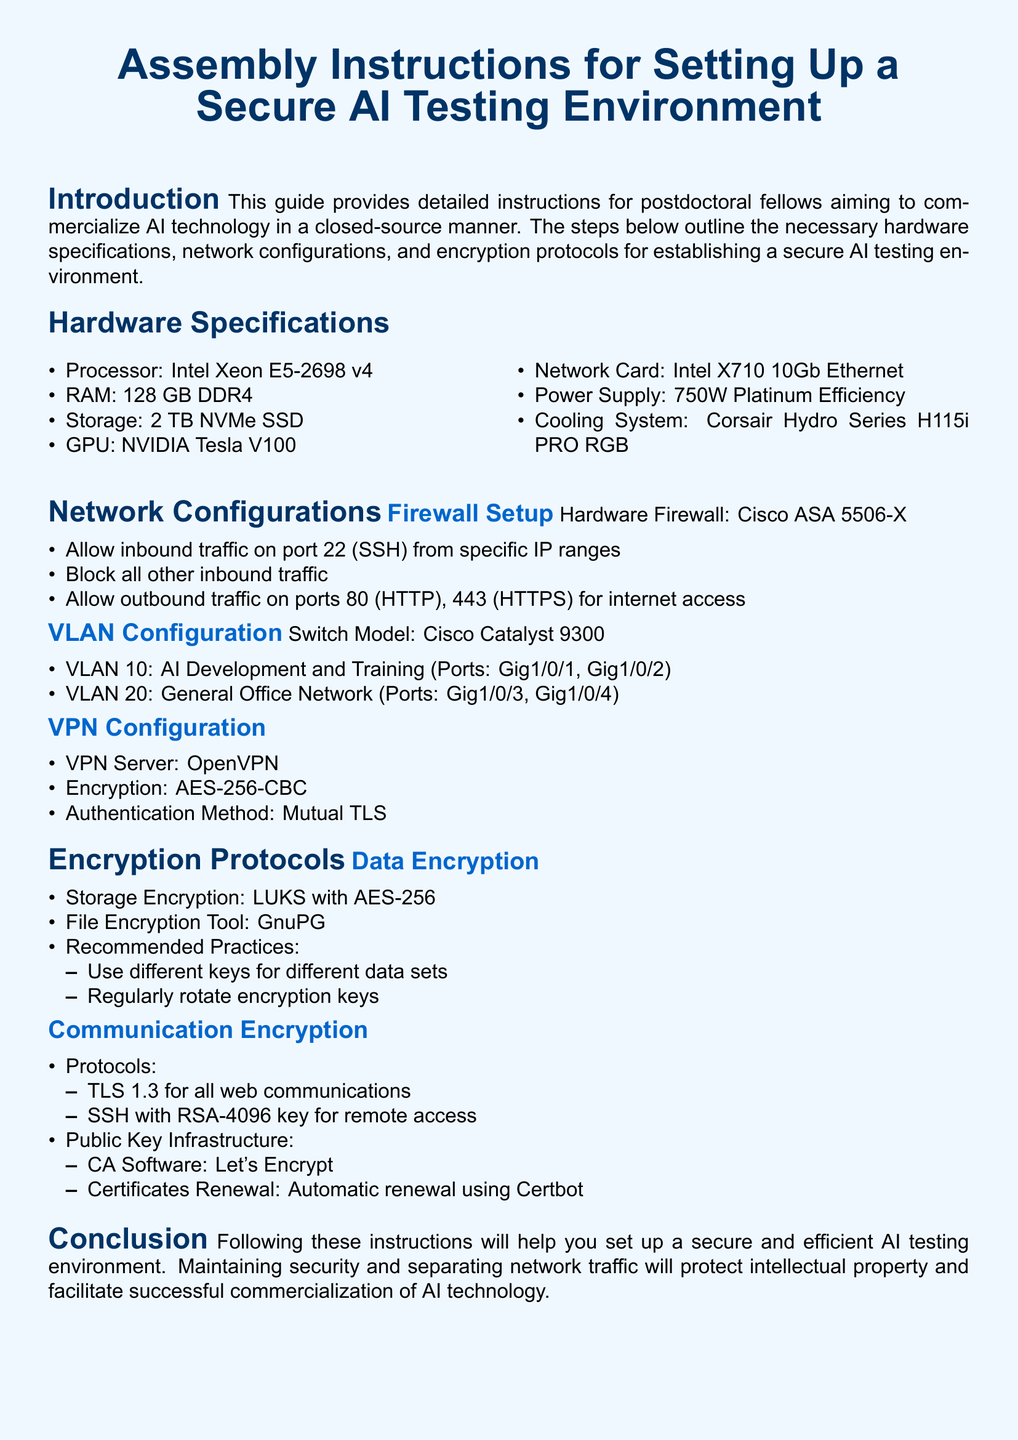What is the recommended RAM? The document specifies that the recommended RAM for the AI testing environment is 128 GB DDR4.
Answer: 128 GB DDR4 What is the encryption method for VPN? The document states that the encryption method for the VPN server is AES-256-CBC.
Answer: AES-256-CBC What ports should allow inbound traffic on the hardware firewall? According to the document, inbound traffic should be allowed on port 22 for SSH from specific IP ranges.
Answer: port 22 What processor is recommended? The processor specified in the document for the AI testing environment is Intel Xeon E5-2698 v4.
Answer: Intel Xeon E5-2698 v4 What is the storage encryption standard mentioned? The document mentions LUKS with AES-256 as the storage encryption standard.
Answer: LUKS with AES-256 How many VLANs are configured? The document lists two VLANs configured for the secure AI testing environment.
Answer: two What is the power supply requirement mentioned? The power supply requirement specified in the document is 750W Platinum Efficiency.
Answer: 750W Platinum Efficiency What is the recommended cooling system? The document recommends using the Corsair Hydro Series H115i PRO RGB as the cooling system.
Answer: Corsair Hydro Series H115i PRO RGB What tool is recommended for file encryption? According to the document, GnuPG is the recommended tool for file encryption.
Answer: GnuPG 